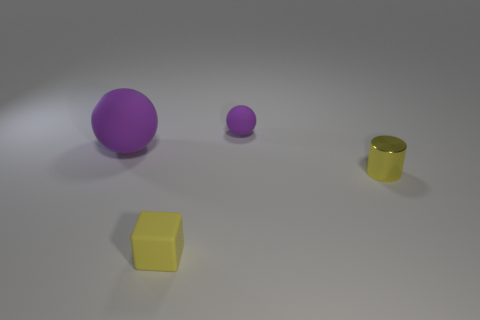How big is the rubber ball to the right of the matte object on the left side of the tiny thing in front of the yellow cylinder?
Your response must be concise. Small. Is there anything else that has the same color as the tiny rubber cube?
Give a very brief answer. Yes. There is a yellow object on the left side of the tiny rubber thing that is behind the rubber thing in front of the large rubber sphere; what is its material?
Your answer should be compact. Rubber. Is the yellow matte thing the same shape as the large purple thing?
Offer a terse response. No. Are there any other things that are the same material as the tiny yellow cube?
Ensure brevity in your answer.  Yes. What number of matte objects are right of the big object and behind the yellow shiny object?
Offer a terse response. 1. What is the color of the sphere that is on the right side of the purple rubber thing that is left of the yellow matte cube?
Give a very brief answer. Purple. Are there an equal number of yellow cylinders right of the cylinder and metallic objects?
Your answer should be compact. No. There is a purple ball behind the rubber ball that is to the left of the tiny purple object; how many large spheres are to the right of it?
Make the answer very short. 0. There is a ball behind the big purple thing; what color is it?
Offer a terse response. Purple. 